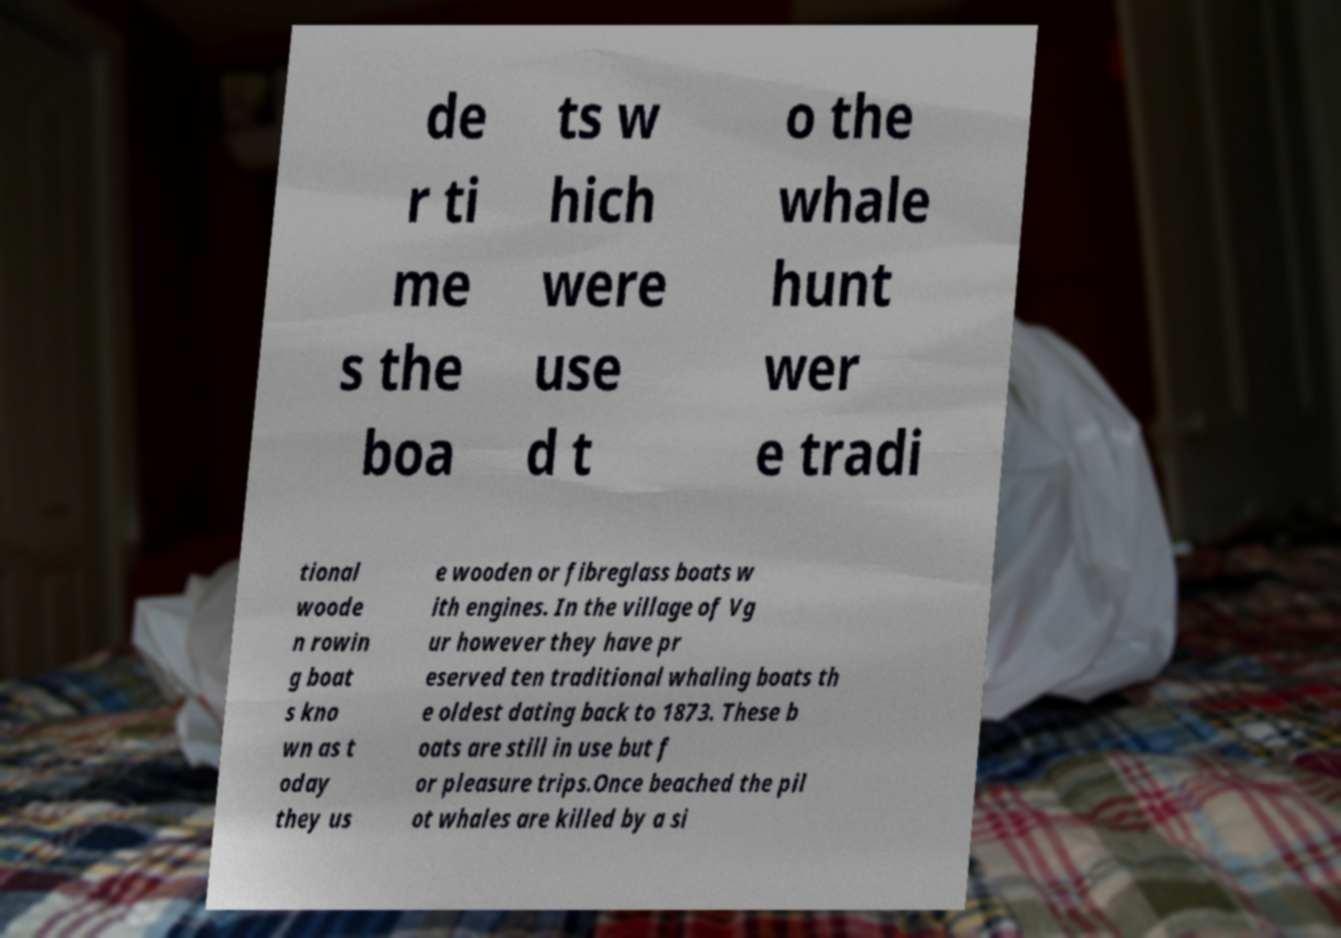What messages or text are displayed in this image? I need them in a readable, typed format. de r ti me s the boa ts w hich were use d t o the whale hunt wer e tradi tional woode n rowin g boat s kno wn as t oday they us e wooden or fibreglass boats w ith engines. In the village of Vg ur however they have pr eserved ten traditional whaling boats th e oldest dating back to 1873. These b oats are still in use but f or pleasure trips.Once beached the pil ot whales are killed by a si 